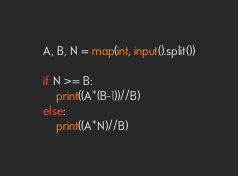<code> <loc_0><loc_0><loc_500><loc_500><_Python_>A, B, N = map(int, input().split())

if N >= B:
    print((A*(B-1))//B)
else:
    print((A*N)//B)</code> 